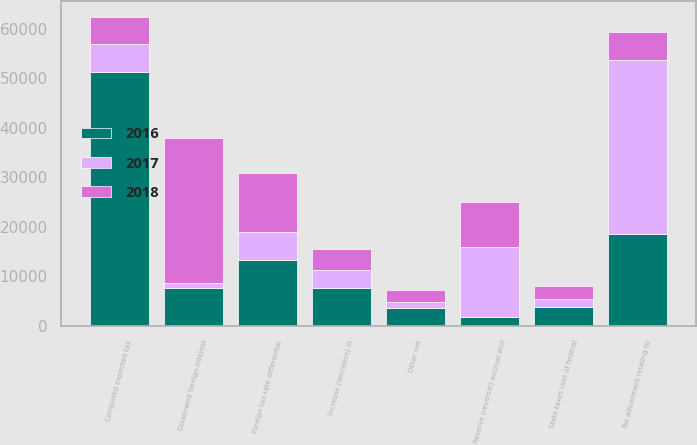Convert chart. <chart><loc_0><loc_0><loc_500><loc_500><stacked_bar_chart><ecel><fcel>Computed expected tax<fcel>Tax adjustment relating to<fcel>State taxes (net of federal<fcel>Increase (decrease) in<fcel>Reserve (reversal) accrual and<fcel>Foreign tax rate differential<fcel>Disallowed foreign interest<fcel>Other net<nl><fcel>2016<fcel>51325<fcel>18526<fcel>3796<fcel>7660<fcel>1898<fcel>13328<fcel>7773<fcel>3589<nl><fcel>2018<fcel>5545<fcel>5545<fcel>2692<fcel>4317<fcel>9103<fcel>11949<fcel>29325<fcel>2256<nl><fcel>2017<fcel>5545<fcel>35165<fcel>1599<fcel>3568<fcel>13985<fcel>5545<fcel>903<fcel>1363<nl></chart> 